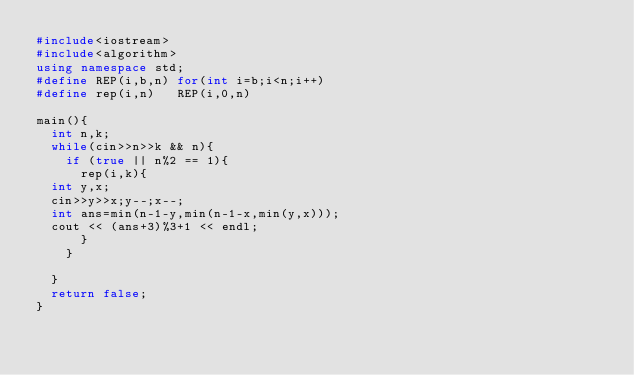<code> <loc_0><loc_0><loc_500><loc_500><_C++_>#include<iostream>
#include<algorithm>
using namespace std;
#define REP(i,b,n) for(int i=b;i<n;i++)
#define rep(i,n)   REP(i,0,n)

main(){
  int n,k;
  while(cin>>n>>k && n){
    if (true || n%2 == 1){
      rep(i,k){
	int y,x;
	cin>>y>>x;y--;x--;
	int ans=min(n-1-y,min(n-1-x,min(y,x)));
	cout << (ans+3)%3+1 << endl;
      }
    }
    
  }
  return false;
}</code> 